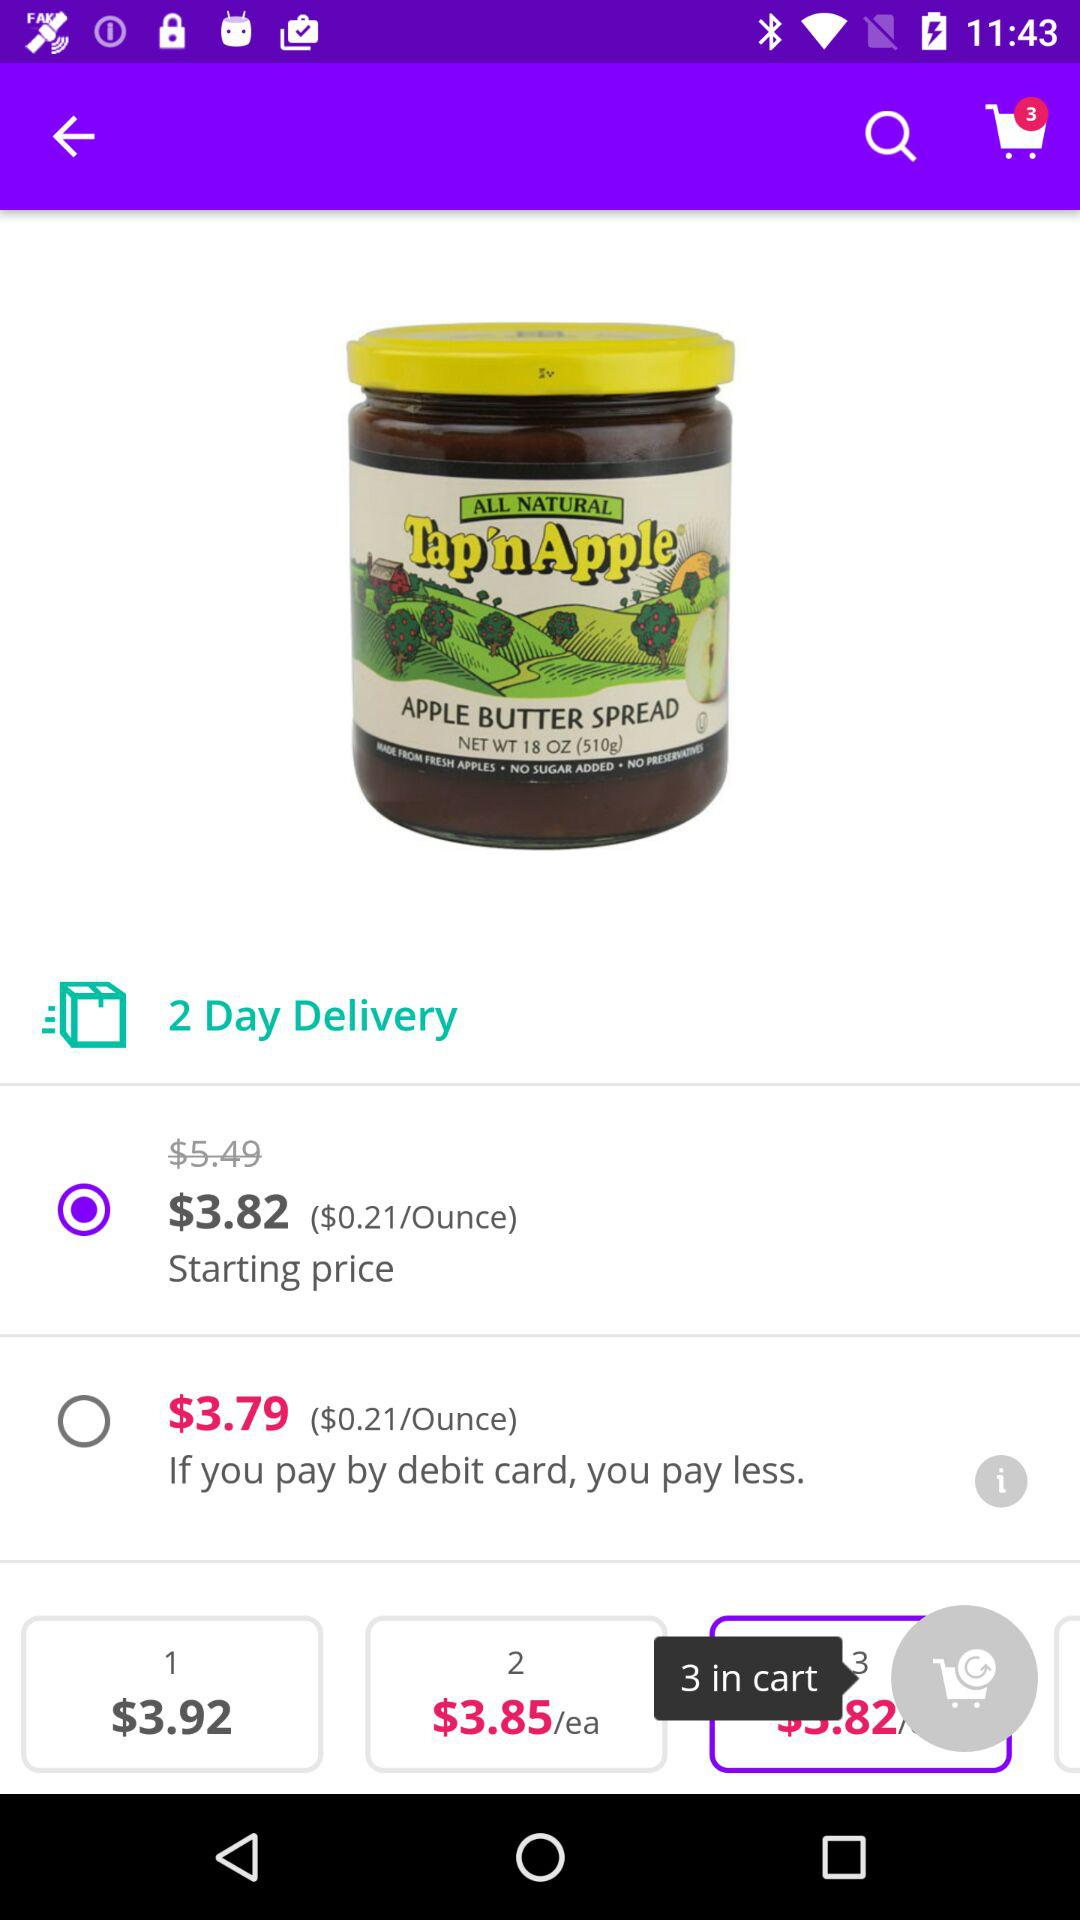Which option has been selected? The selected option is "$3.82". 